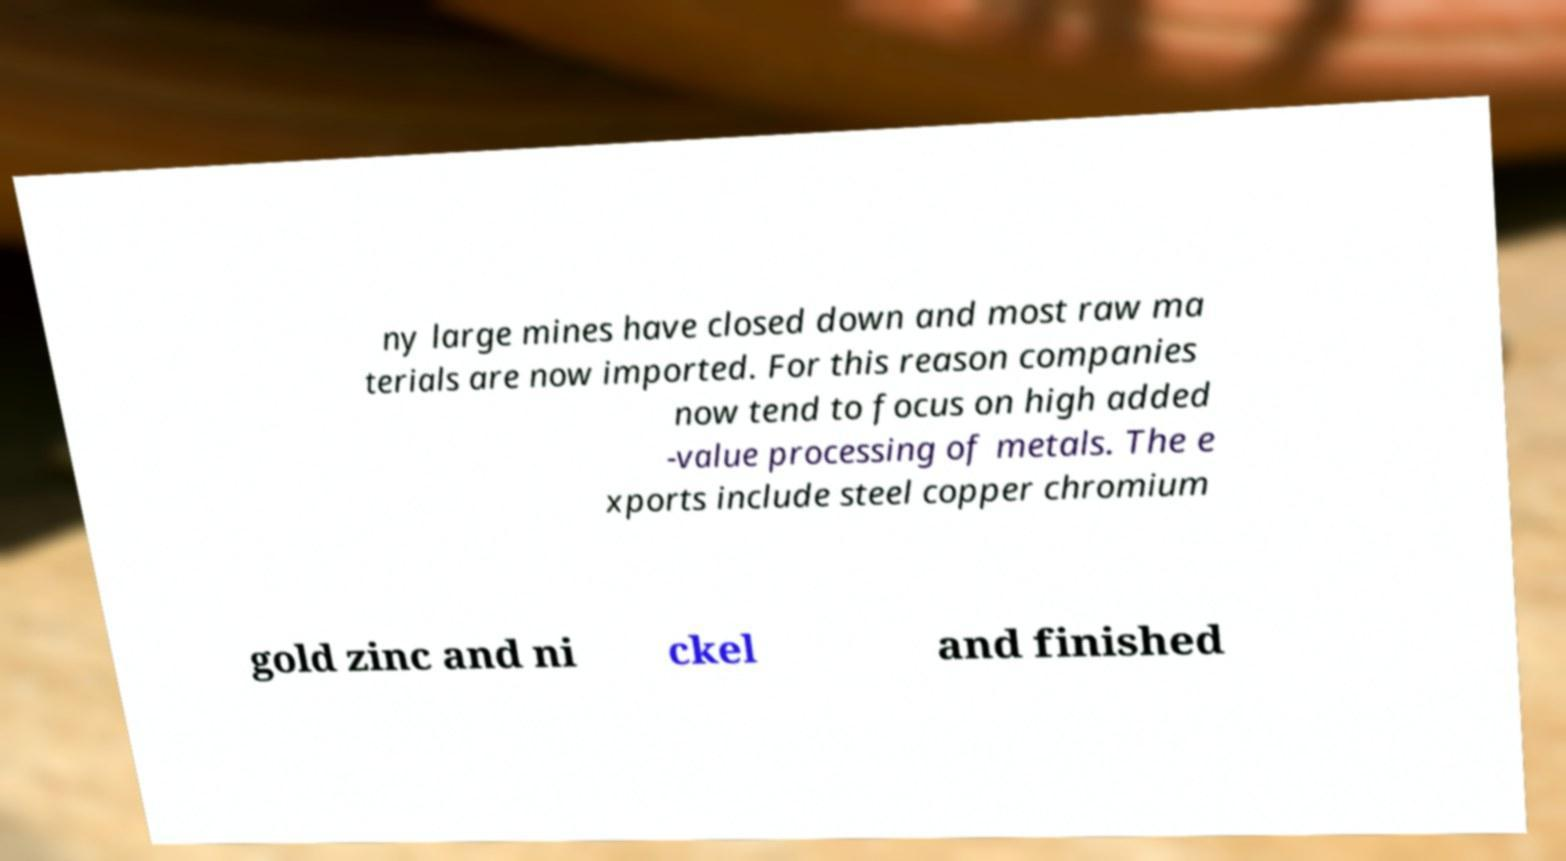Please identify and transcribe the text found in this image. ny large mines have closed down and most raw ma terials are now imported. For this reason companies now tend to focus on high added -value processing of metals. The e xports include steel copper chromium gold zinc and ni ckel and finished 